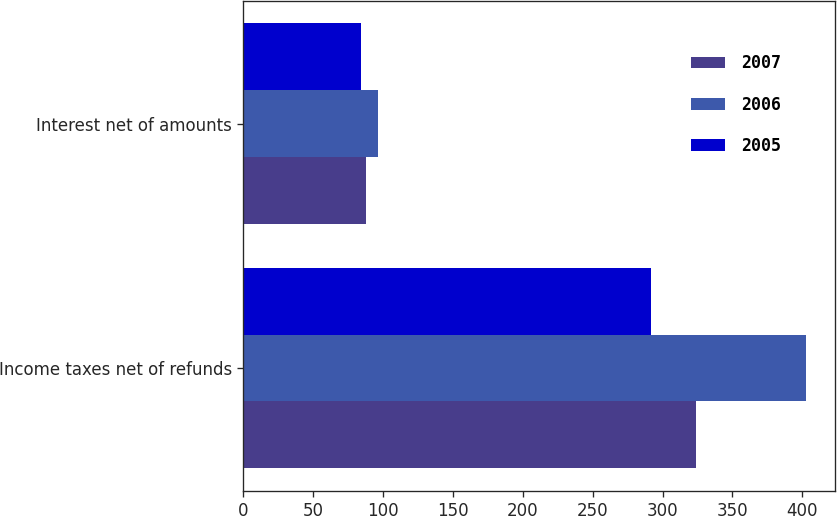Convert chart. <chart><loc_0><loc_0><loc_500><loc_500><stacked_bar_chart><ecel><fcel>Income taxes net of refunds<fcel>Interest net of amounts<nl><fcel>2007<fcel>324<fcel>88<nl><fcel>2006<fcel>403<fcel>96<nl><fcel>2005<fcel>292<fcel>84<nl></chart> 